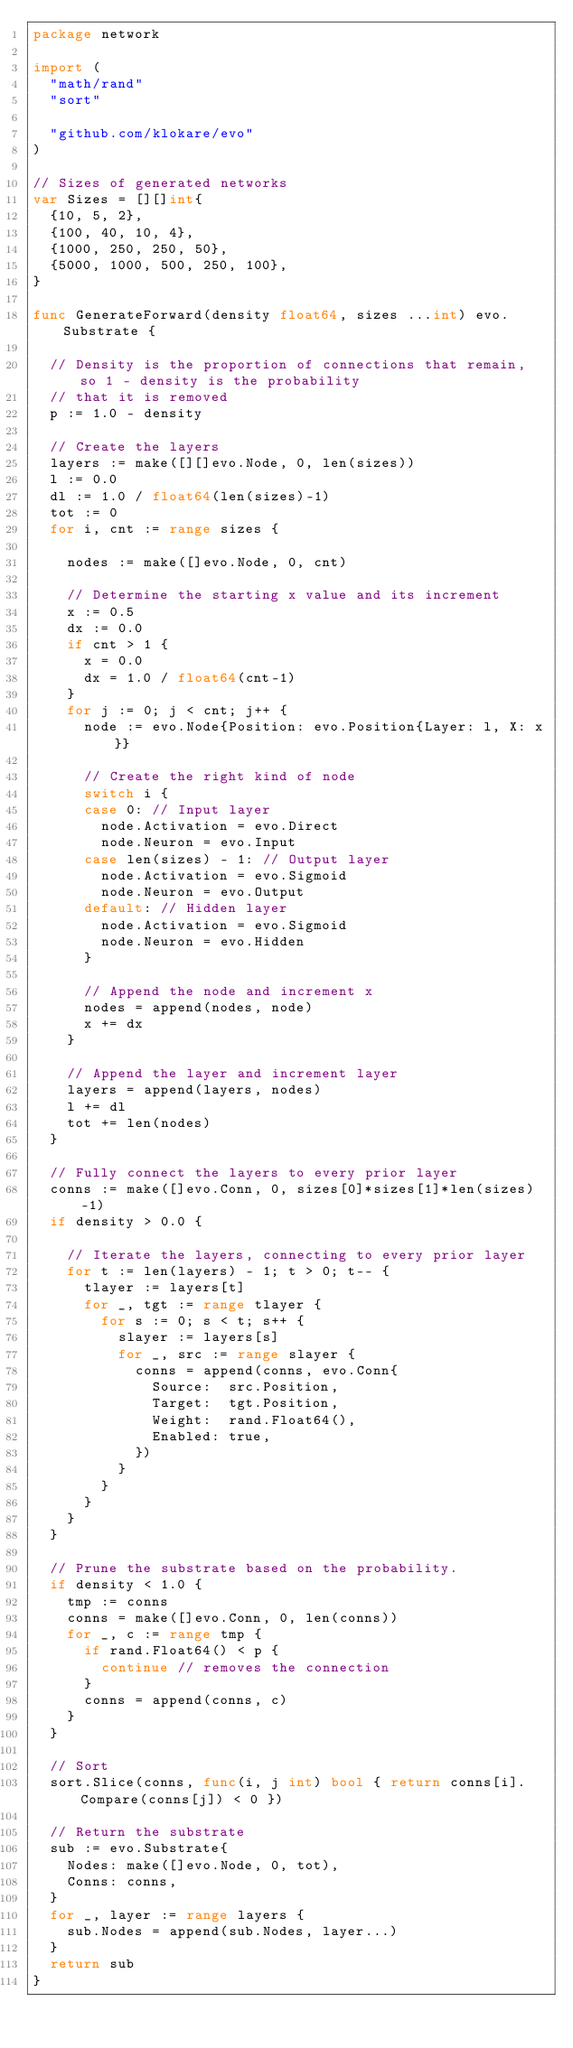Convert code to text. <code><loc_0><loc_0><loc_500><loc_500><_Go_>package network

import (
	"math/rand"
	"sort"

	"github.com/klokare/evo"
)

// Sizes of generated networks
var Sizes = [][]int{
	{10, 5, 2},
	{100, 40, 10, 4},
	{1000, 250, 250, 50},
	{5000, 1000, 500, 250, 100},
}

func GenerateForward(density float64, sizes ...int) evo.Substrate {

	// Density is the proportion of connections that remain, so 1 - density is the probability
	// that it is removed
	p := 1.0 - density

	// Create the layers
	layers := make([][]evo.Node, 0, len(sizes))
	l := 0.0
	dl := 1.0 / float64(len(sizes)-1)
	tot := 0
	for i, cnt := range sizes {

		nodes := make([]evo.Node, 0, cnt)

		// Determine the starting x value and its increment
		x := 0.5
		dx := 0.0
		if cnt > 1 {
			x = 0.0
			dx = 1.0 / float64(cnt-1)
		}
		for j := 0; j < cnt; j++ {
			node := evo.Node{Position: evo.Position{Layer: l, X: x}}

			// Create the right kind of node
			switch i {
			case 0: // Input layer
				node.Activation = evo.Direct
				node.Neuron = evo.Input
			case len(sizes) - 1: // Output layer
				node.Activation = evo.Sigmoid
				node.Neuron = evo.Output
			default: // Hidden layer
				node.Activation = evo.Sigmoid
				node.Neuron = evo.Hidden
			}

			// Append the node and increment x
			nodes = append(nodes, node)
			x += dx
		}

		// Append the layer and increment layer
		layers = append(layers, nodes)
		l += dl
		tot += len(nodes)
	}

	// Fully connect the layers to every prior layer
	conns := make([]evo.Conn, 0, sizes[0]*sizes[1]*len(sizes)-1)
	if density > 0.0 {

		// Iterate the layers, connecting to every prior layer
		for t := len(layers) - 1; t > 0; t-- {
			tlayer := layers[t]
			for _, tgt := range tlayer {
				for s := 0; s < t; s++ {
					slayer := layers[s]
					for _, src := range slayer {
						conns = append(conns, evo.Conn{
							Source:  src.Position,
							Target:  tgt.Position,
							Weight:  rand.Float64(),
							Enabled: true,
						})
					}
				}
			}
		}
	}

	// Prune the substrate based on the probability.
	if density < 1.0 {
		tmp := conns
		conns = make([]evo.Conn, 0, len(conns))
		for _, c := range tmp {
			if rand.Float64() < p {
				continue // removes the connection
			}
			conns = append(conns, c)
		}
	}

	// Sort
	sort.Slice(conns, func(i, j int) bool { return conns[i].Compare(conns[j]) < 0 })

	// Return the substrate
	sub := evo.Substrate{
		Nodes: make([]evo.Node, 0, tot),
		Conns: conns,
	}
	for _, layer := range layers {
		sub.Nodes = append(sub.Nodes, layer...)
	}
	return sub
}
</code> 